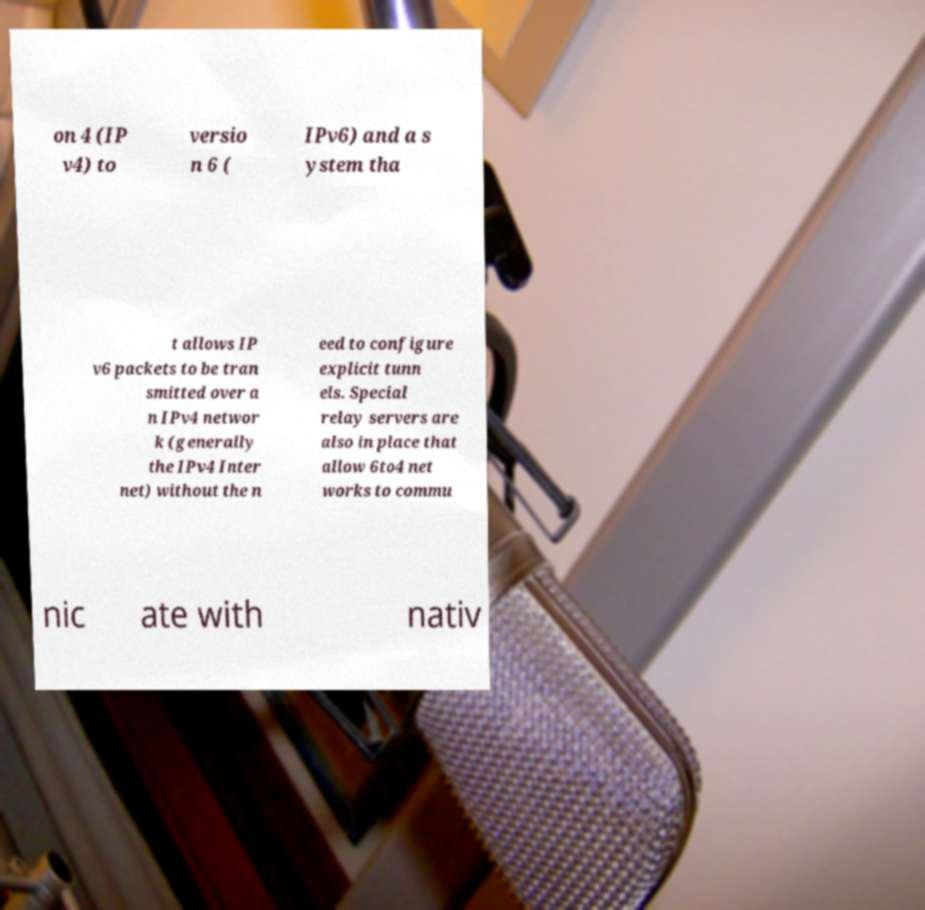Can you accurately transcribe the text from the provided image for me? on 4 (IP v4) to versio n 6 ( IPv6) and a s ystem tha t allows IP v6 packets to be tran smitted over a n IPv4 networ k (generally the IPv4 Inter net) without the n eed to configure explicit tunn els. Special relay servers are also in place that allow 6to4 net works to commu nic ate with nativ 